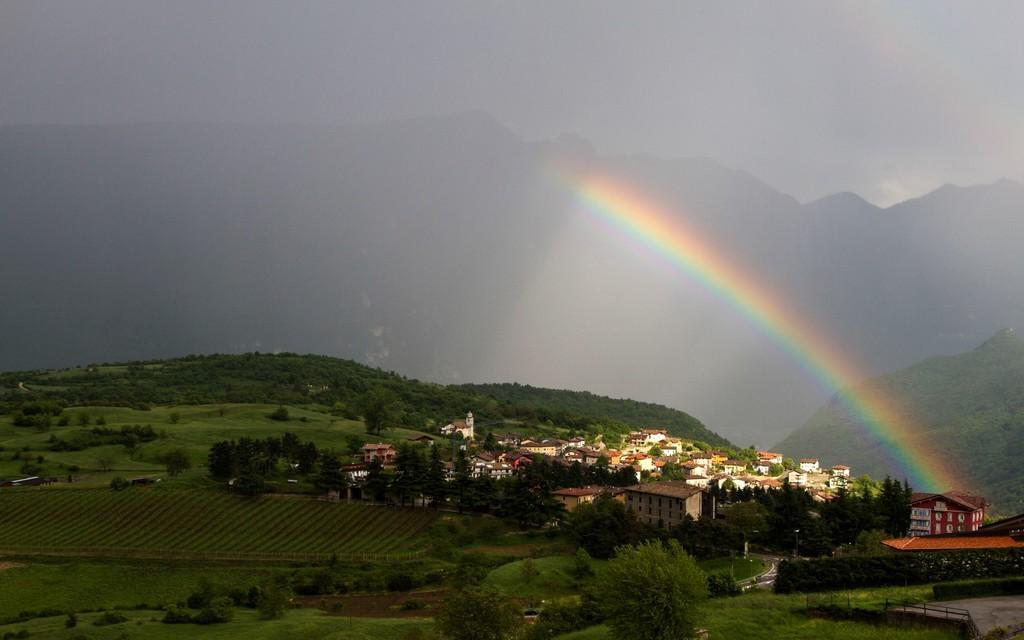Describe this image in one or two sentences. On the right side, there is a rainbow, there are buildings, trees, plants and grass on the ground. On the left side, there are trees, buildings, plants and grass on the ground. In the background, there are mountains and there are clouds in the sky. 